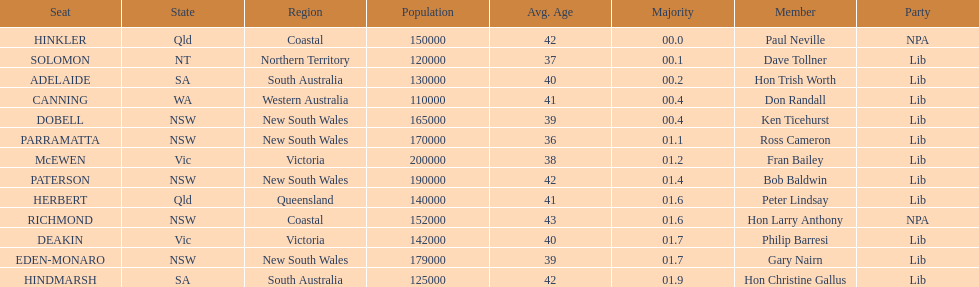What is the total of seats? 13. Can you parse all the data within this table? {'header': ['Seat', 'State', 'Region', 'Population', 'Avg. Age', 'Majority', 'Member', 'Party'], 'rows': [['HINKLER', 'Qld', 'Coastal', '150000', '42', '00.0', 'Paul Neville', 'NPA'], ['SOLOMON', 'NT', 'Northern Territory', '120000', '37', '00.1', 'Dave Tollner', 'Lib'], ['ADELAIDE', 'SA', 'South Australia', '130000', '40', '00.2', 'Hon Trish Worth', 'Lib'], ['CANNING', 'WA', 'Western Australia', '110000', '41', '00.4', 'Don Randall', 'Lib'], ['DOBELL', 'NSW', 'New South Wales', '165000', '39', '00.4', 'Ken Ticehurst', 'Lib'], ['PARRAMATTA', 'NSW', 'New South Wales', '170000', '36', '01.1', 'Ross Cameron', 'Lib'], ['McEWEN', 'Vic', 'Victoria', '200000', '38', '01.2', 'Fran Bailey', 'Lib'], ['PATERSON', 'NSW', 'New South Wales', '190000', '42', '01.4', 'Bob Baldwin', 'Lib'], ['HERBERT', 'Qld', 'Queensland', '140000', '41', '01.6', 'Peter Lindsay', 'Lib'], ['RICHMOND', 'NSW', 'Coastal', '152000', '43', '01.6', 'Hon Larry Anthony', 'NPA'], ['DEAKIN', 'Vic', 'Victoria', '142000', '40', '01.7', 'Philip Barresi', 'Lib'], ['EDEN-MONARO', 'NSW', 'New South Wales', '179000', '39', '01.7', 'Gary Nairn', 'Lib'], ['HINDMARSH', 'SA', 'South Australia', '125000', '42', '01.9', 'Hon Christine Gallus', 'Lib']]} 